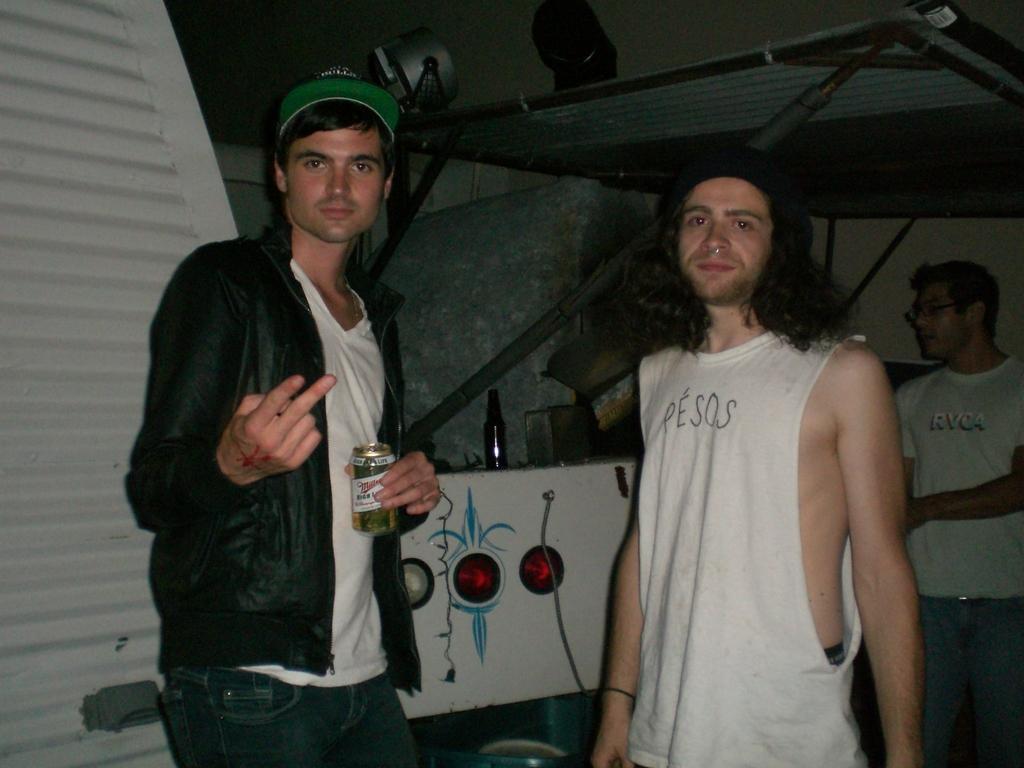Can you describe this image briefly? In this picture we can see three men standing, a man on the left side is holding a tin, in the background we can see lights and a bottle, there are two lights at the top of the picture. 